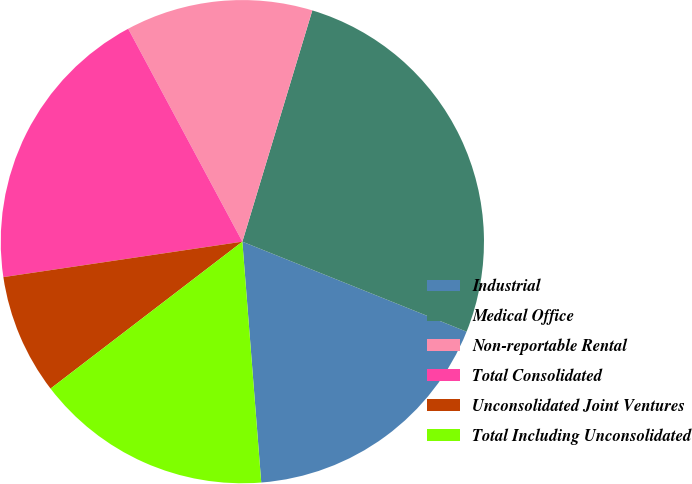Convert chart. <chart><loc_0><loc_0><loc_500><loc_500><pie_chart><fcel>Industrial<fcel>Medical Office<fcel>Non-reportable Rental<fcel>Total Consolidated<fcel>Unconsolidated Joint Ventures<fcel>Total Including Unconsolidated<nl><fcel>17.68%<fcel>26.4%<fcel>12.51%<fcel>19.51%<fcel>8.06%<fcel>15.84%<nl></chart> 